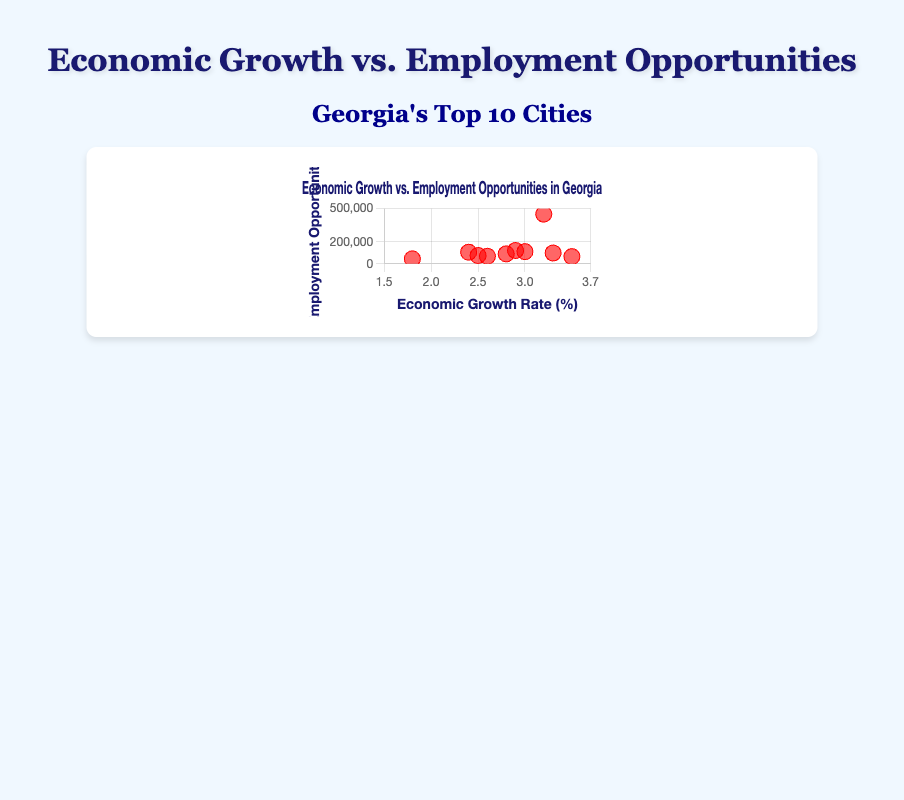What is the title of the scatter plot? The title of the scatter plot is prominently displayed at the top of the figure and provides context to the data being presented. The title reads "Economic Growth vs. Employment Opportunities in Georgia".
Answer: Economic Growth vs. Employment Opportunities in Georgia What is the color of the data points in the scatter plot? The color of the data points is visually noticeable and is uniform across all points, being a shade of red.
Answer: Red How many cities are represented in the scatter plot? By examining each individual data point or referring to the scatter plot's legend, we see labels indicating there are 10 cities.
Answer: 10 What does the x-axis represent in the scatter plot? The x-axis indicates the variable being measured along the horizontal plane, which in this figure is "Economic Growth Rate (%)".
Answer: Economic Growth Rate (%) What city has the highest economic growth rate? By finding the data point farthest to the right on the x-axis, we identify "Athens" with a 3.5% growth rate, as labeled beside it.
Answer: Athens Which city offers the most employment opportunities? Observing the data point positioned highest on the y-axis reveals "Atlanta" has the highest employment opportunities at 450,000.
Answer: Atlanta What is the economic growth rate for Warner Robins? Locate the data point labeled "Warner Robins" and refer to its x-coordinate, which shows a 2.4% economic growth rate.
Answer: 2.4% Which cities have both a growth rate above 3.0% and employment opportunities below 100,000? Analyze the scatter plot for data points right of 3.0% on the x-axis and below 100,000 on the y-axis, revealing "Athens" (3.5%, 65,000) and "Roswell" (3.3%, 98,000).
Answer: Athens, Roswell What is the difference in employment opportunities between Augusta and Macon? Subtract the employment opportunities of Macon (68,000) from Augusta (110,000) which equals 110,000 - 68,000 = 42,000.
Answer: 42,000 Which city has an economic growth rate between 2.5% and 3.0% and how many employment opportunities does it offer? Find a data point between 2.5% and 3.0% on the x-axis, "Columbus" (2.5%, 75,000), "Savannah" (2.8%, 90,000), "Stone Mountain" (2.9%, 120,000).
Answer: Columbus: 75,000; Savannah: 90,000; Stone Mountain: 120,000 